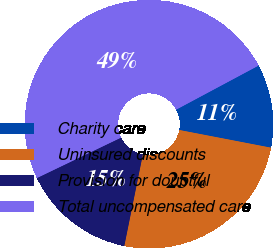<chart> <loc_0><loc_0><loc_500><loc_500><pie_chart><fcel>Charity care<fcel>Uninsured discounts<fcel>Provision for doubtful<fcel>Total uncompensated care<nl><fcel>10.85%<fcel>25.15%<fcel>14.69%<fcel>49.31%<nl></chart> 